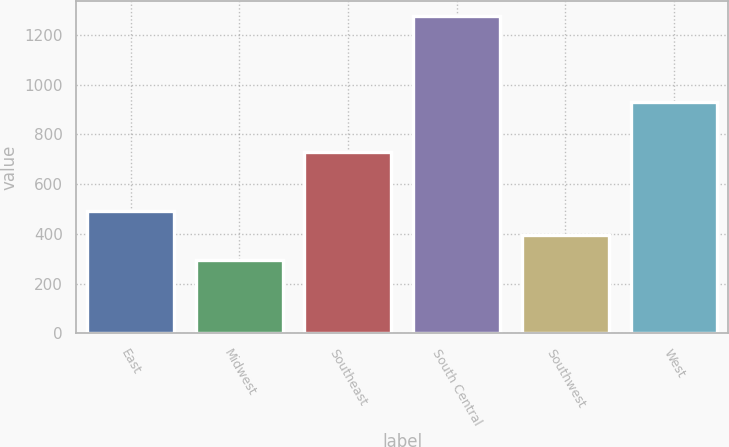<chart> <loc_0><loc_0><loc_500><loc_500><bar_chart><fcel>East<fcel>Midwest<fcel>Southeast<fcel>South Central<fcel>Southwest<fcel>West<nl><fcel>491.48<fcel>296<fcel>728.7<fcel>1273.4<fcel>393.74<fcel>928.6<nl></chart> 